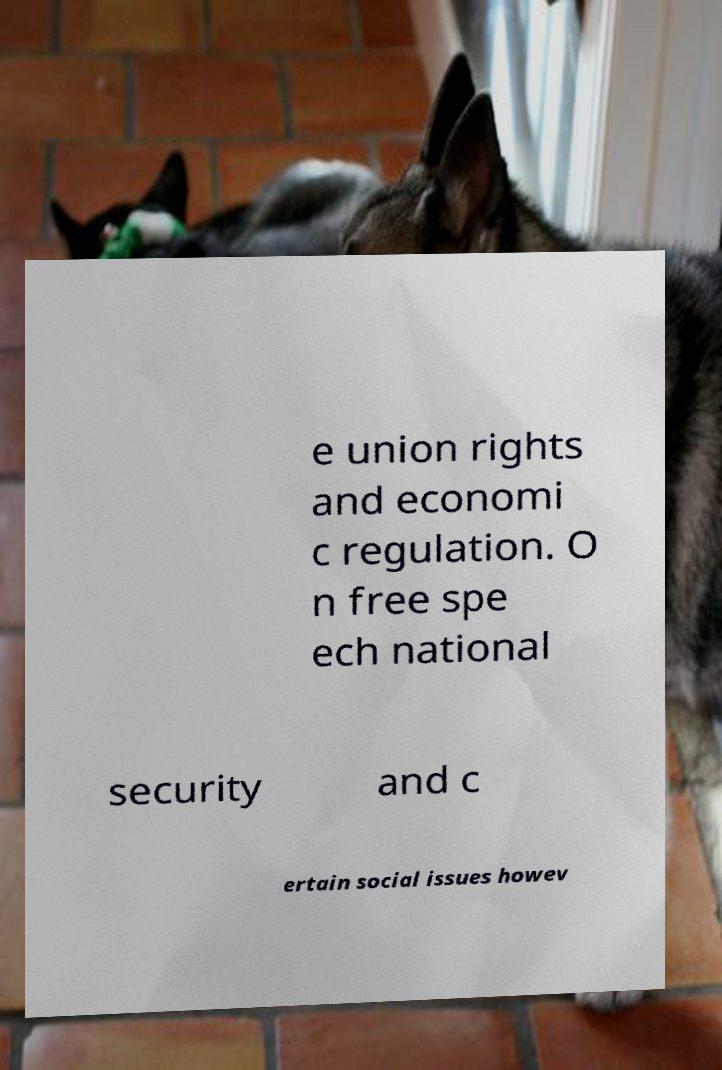I need the written content from this picture converted into text. Can you do that? e union rights and economi c regulation. O n free spe ech national security and c ertain social issues howev 